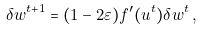<formula> <loc_0><loc_0><loc_500><loc_500>\delta w ^ { t + 1 } = ( 1 - 2 \varepsilon ) f ^ { \prime } ( u ^ { t } ) \delta w ^ { t } \, ,</formula> 